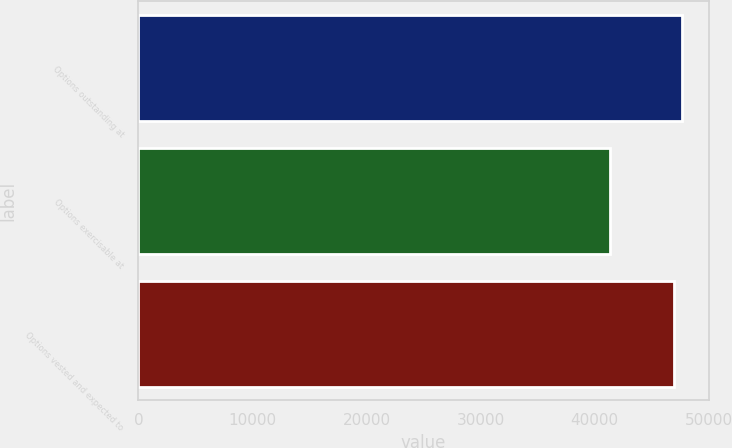<chart> <loc_0><loc_0><loc_500><loc_500><bar_chart><fcel>Options outstanding at<fcel>Options exercisable at<fcel>Options vested and expected to<nl><fcel>47630<fcel>41310<fcel>46946<nl></chart> 